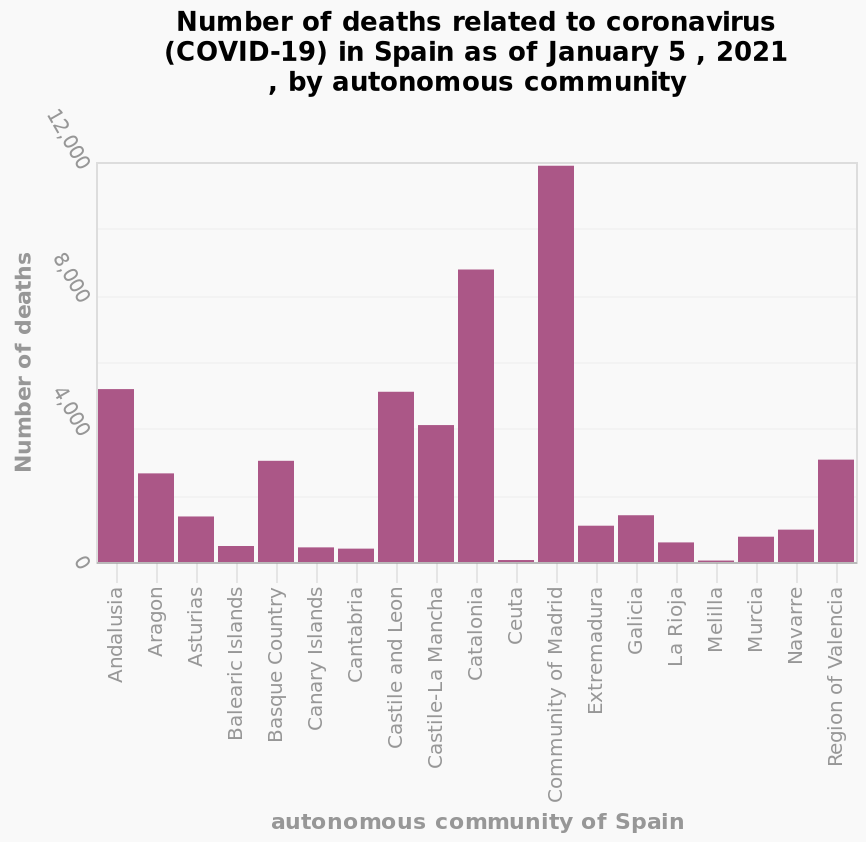<image>
Describe the following image in detail Number of deaths related to coronavirus (COVID-19) in Spain as of January 5 , 2021 , by autonomous community is a bar diagram. The x-axis plots autonomous community of Spain along categorical scale with Andalusia on one end and Region of Valencia at the other while the y-axis measures Number of deaths using linear scale of range 0 to 12,000. 